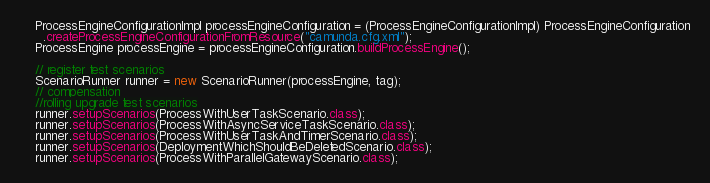<code> <loc_0><loc_0><loc_500><loc_500><_Java_>    ProcessEngineConfigurationImpl processEngineConfiguration = (ProcessEngineConfigurationImpl) ProcessEngineConfiguration
      .createProcessEngineConfigurationFromResource("camunda.cfg.xml");
    ProcessEngine processEngine = processEngineConfiguration.buildProcessEngine();

    // register test scenarios
    ScenarioRunner runner = new ScenarioRunner(processEngine, tag);
    // compensation
    //rolling upgrade test scenarios
    runner.setupScenarios(ProcessWithUserTaskScenario.class);
    runner.setupScenarios(ProcessWithAsyncServiceTaskScenario.class);
    runner.setupScenarios(ProcessWithUserTaskAndTimerScenario.class);
    runner.setupScenarios(DeploymentWhichShouldBeDeletedScenario.class);
    runner.setupScenarios(ProcessWithParallelGatewayScenario.class);</code> 